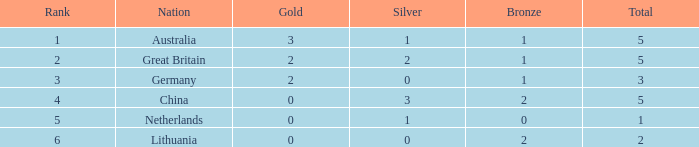What is the ranking number when gold is below 0? None. 